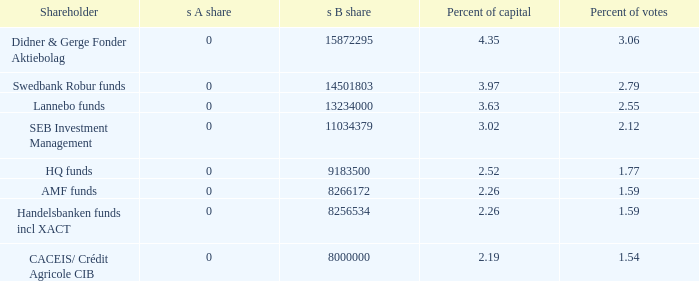What investor holds Lannebo funds. 